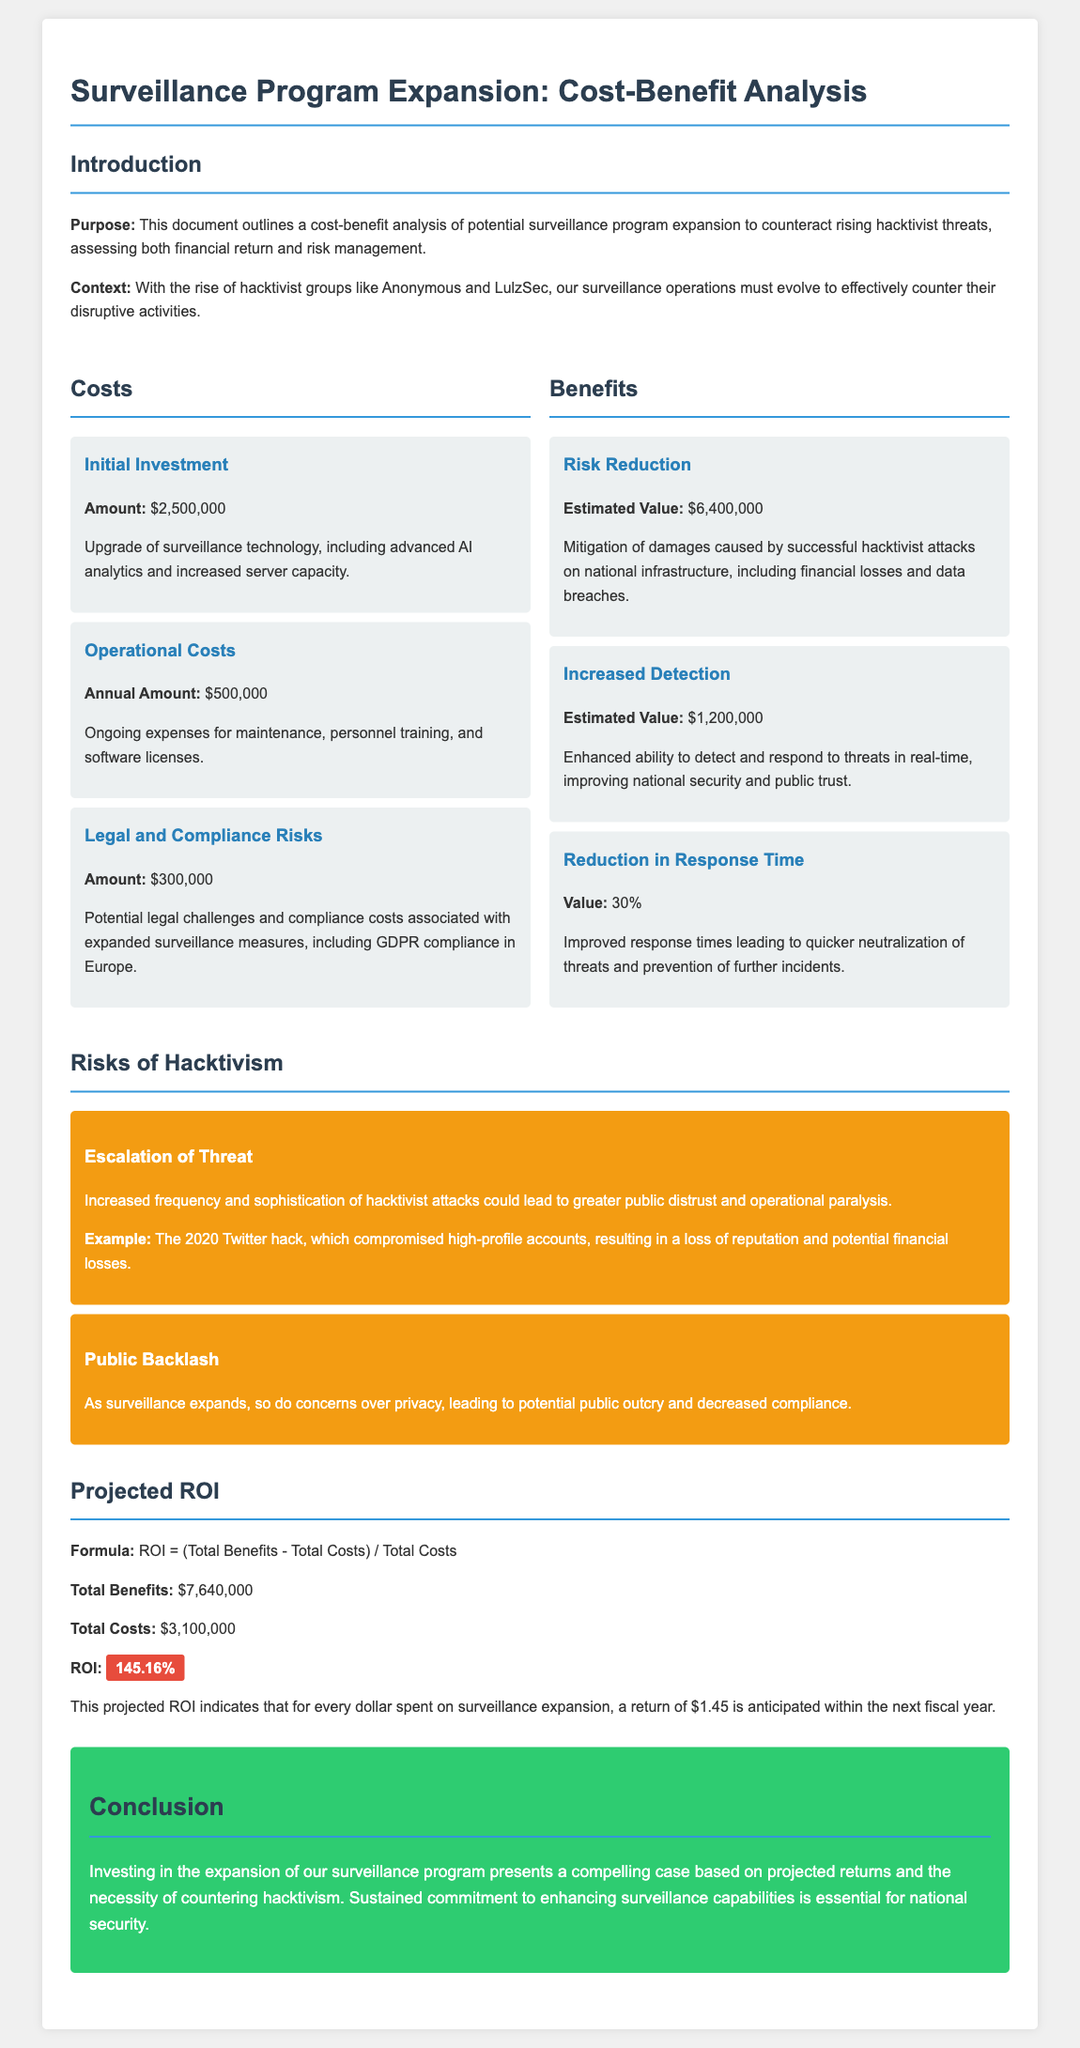What is the initial investment amount for the surveillance program? The initial investment amount for the surveillance program is specified as $2,500,000.
Answer: $2,500,000 What are the annual operational costs? The document states that the annual operational costs are $500,000.
Answer: $500,000 What is the estimated value of risk reduction? The estimated value of risk reduction is provided as $6,400,000 in the benefits section.
Answer: $6,400,000 What is the projected ROI? The projected ROI is calculated and highlighted as 145.16%.
Answer: 145.16% What are the legal and compliance risks amount? The legal and compliance risks amount is indicated as $300,000 in the costs section.
Answer: $300,000 What percentage reduction in response time is mentioned? The reduction in response time is stated as 30% in the benefits section.
Answer: 30% What is the formula used to calculate ROI? The formula used to calculate ROI is provided as Total Benefits minus Total Costs divided by Total Costs.
Answer: Total Benefits - Total Costs / Total Costs What example is given to illustrate escalation of threat? The document cites the 2020 Twitter hack as an example of escalation of threat.
Answer: 2020 Twitter hack What is the conclusion regarding investment in surveillance? The conclusion emphasizes the need for sustained commitment to enhancing surveillance capabilities for national security.
Answer: National security 